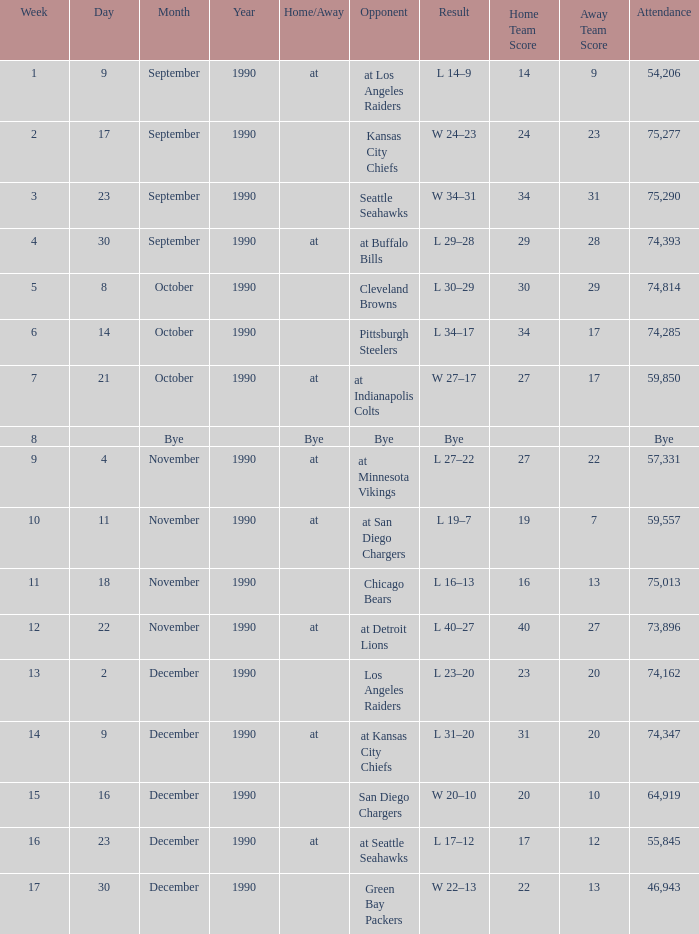What is the latest week with an attendance of 74,162? 13.0. 